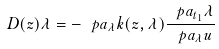<formula> <loc_0><loc_0><loc_500><loc_500>D ( z ) \lambda = - \ p a _ { \lambda } k ( z , \lambda ) \frac { \ p a _ { t _ { 1 } } \lambda } { \ p a _ { \lambda } u }</formula> 